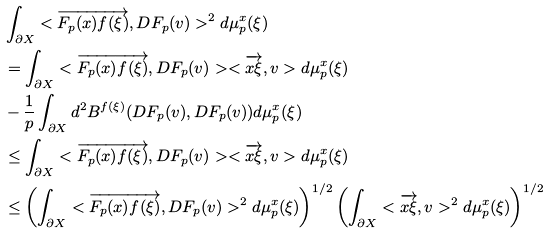<formula> <loc_0><loc_0><loc_500><loc_500>& \int _ { \partial X } < \overrightarrow { F _ { p } ( x ) f ( \xi ) } , D F _ { p } ( v ) > ^ { 2 } d \mu ^ { x } _ { p } ( \xi ) \\ & = \int _ { \partial X } < \overrightarrow { F _ { p } ( x ) f ( \xi ) } , D F _ { p } ( v ) > < \overrightarrow { x \xi } , v > d \mu ^ { x } _ { p } ( \xi ) \\ & - \frac { 1 } { p } \int _ { \partial X } d ^ { 2 } B ^ { f ( \xi ) } ( D F _ { p } ( v ) , D F _ { p } ( v ) ) d \mu ^ { x } _ { p } ( \xi ) \\ & \leq \int _ { \partial X } < \overrightarrow { F _ { p } ( x ) f ( \xi ) } , D F _ { p } ( v ) > < \overrightarrow { x \xi } , v > d \mu ^ { x } _ { p } ( \xi ) \\ & \leq \left ( \int _ { \partial X } < \overrightarrow { F _ { p } ( x ) f ( \xi ) } , D F _ { p } ( v ) > ^ { 2 } d \mu ^ { x } _ { p } ( \xi ) \right ) ^ { 1 / 2 } \left ( \int _ { \partial X } < \overrightarrow { x \xi } , v > ^ { 2 } d \mu ^ { x } _ { p } ( \xi ) \right ) ^ { 1 / 2 } \\</formula> 